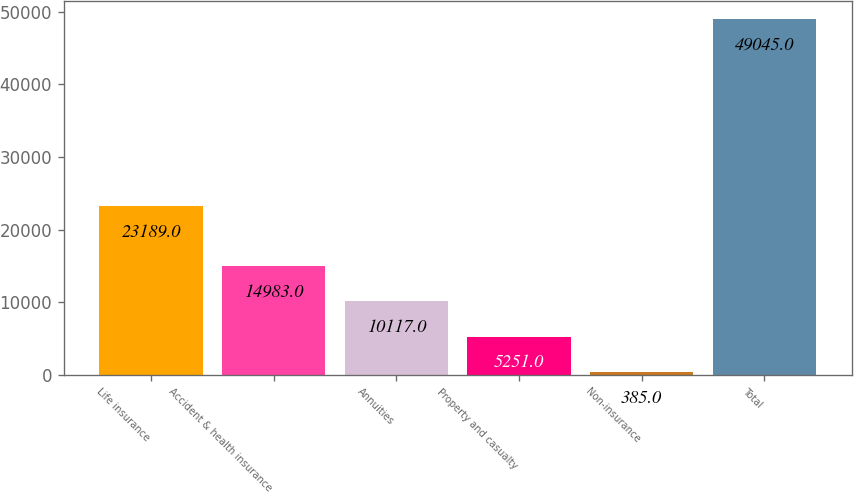<chart> <loc_0><loc_0><loc_500><loc_500><bar_chart><fcel>Life insurance<fcel>Accident & health insurance<fcel>Annuities<fcel>Property and casualty<fcel>Non-insurance<fcel>Total<nl><fcel>23189<fcel>14983<fcel>10117<fcel>5251<fcel>385<fcel>49045<nl></chart> 